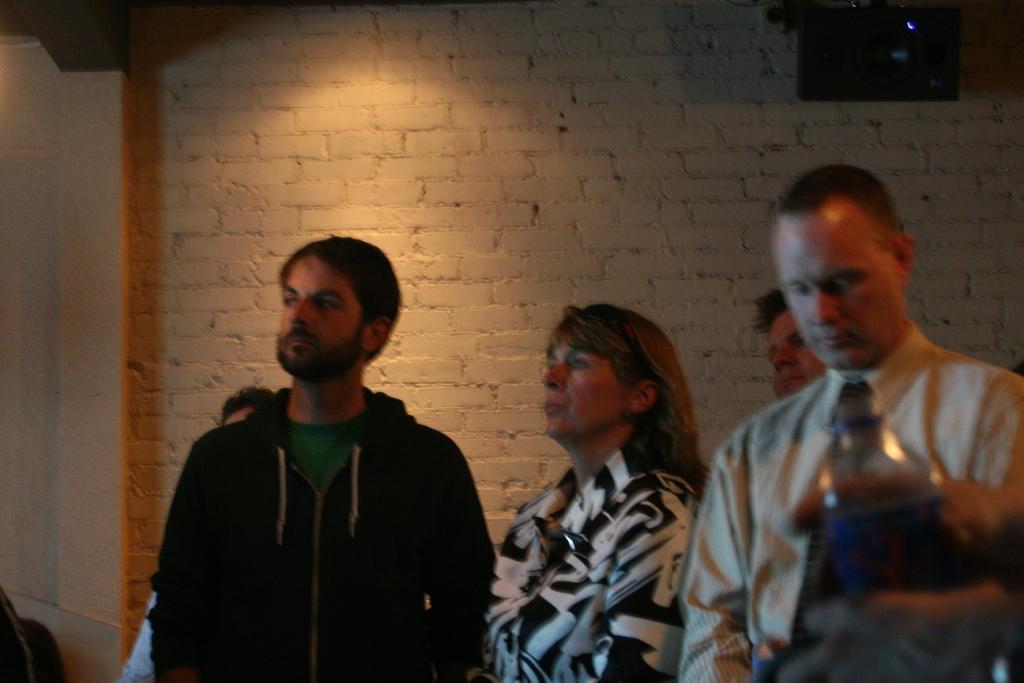Please provide a concise description of this image. In this image there is a person wearing a jacket. Beside him there is a woman. Right side there is a person wearing a shirt and tie. Right bottom a person's hand is visible. He is holding a bottle. There are people. Behind them there is a wall. Right top there is an object attached to the wall. 